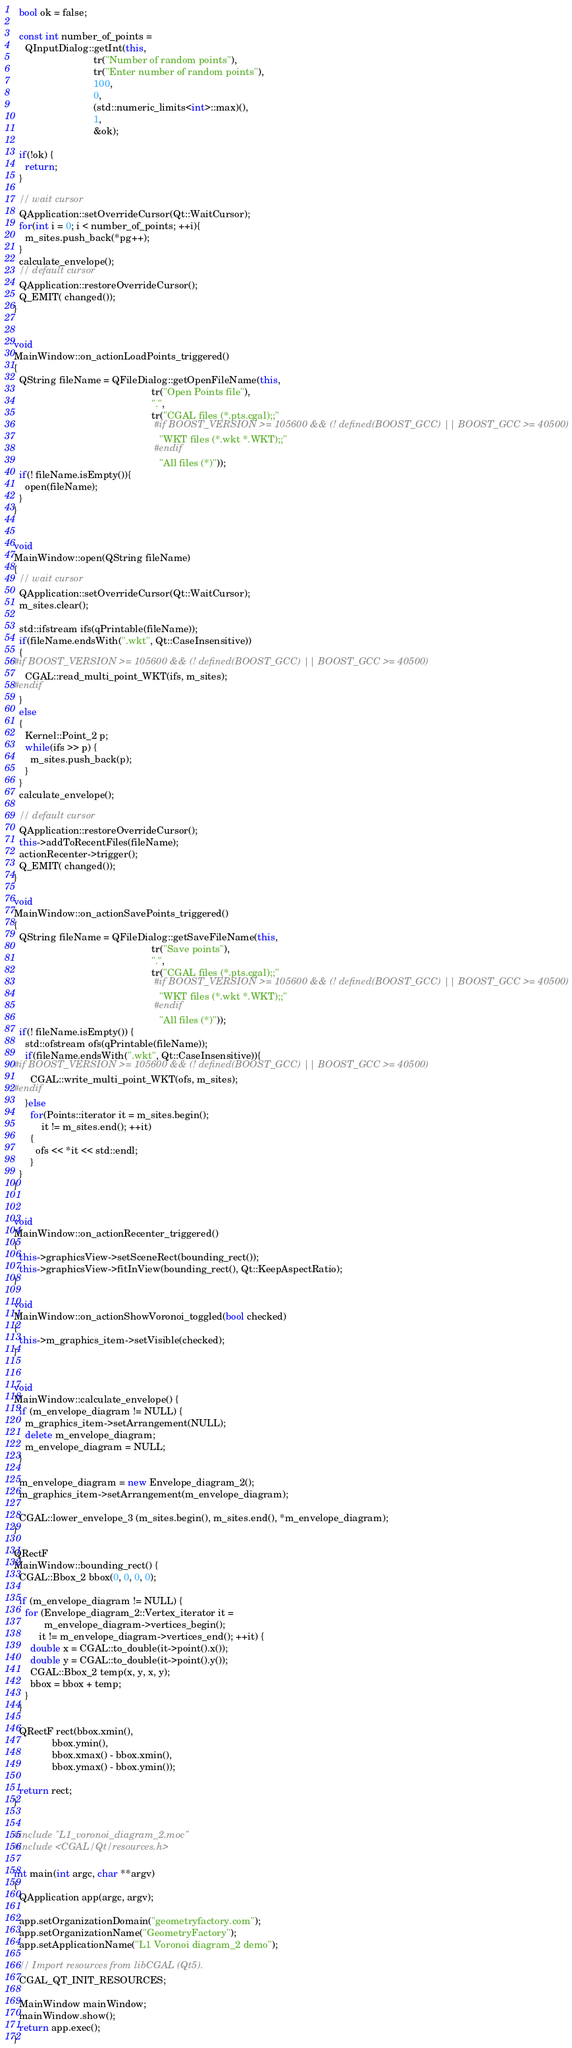<code> <loc_0><loc_0><loc_500><loc_500><_C++_>  bool ok = false;

  const int number_of_points =
    QInputDialog::getInt(this,
                             tr("Number of random points"),
                             tr("Enter number of random points"),
                             100,
                             0,
                             (std::numeric_limits<int>::max)(),
                             1,
                             &ok);

  if(!ok) {
    return;
  }

  // wait cursor
  QApplication::setOverrideCursor(Qt::WaitCursor);
  for(int i = 0; i < number_of_points; ++i){
    m_sites.push_back(*pg++);
  }
  calculate_envelope();
  // default cursor
  QApplication::restoreOverrideCursor();
  Q_EMIT( changed());
}


void
MainWindow::on_actionLoadPoints_triggered()
{
  QString fileName = QFileDialog::getOpenFileName(this,
                                                  tr("Open Points file"),
                                                  ".",
                                                  tr("CGAL files (*.pts.cgal);;"
                                                   #if BOOST_VERSION >= 105600 && (! defined(BOOST_GCC) || BOOST_GCC >= 40500)
                                                     "WKT files (*.wkt *.WKT);;"
                                                   #endif
                                                     "All files (*)"));
  if(! fileName.isEmpty()){
    open(fileName);
  }
}


void
MainWindow::open(QString fileName)
{
  // wait cursor
  QApplication::setOverrideCursor(Qt::WaitCursor);
  m_sites.clear();

  std::ifstream ifs(qPrintable(fileName));
  if(fileName.endsWith(".wkt", Qt::CaseInsensitive))
  {
#if BOOST_VERSION >= 105600 && (! defined(BOOST_GCC) || BOOST_GCC >= 40500)
    CGAL::read_multi_point_WKT(ifs, m_sites);
#endif
  }
  else
  {
    Kernel::Point_2 p;
    while(ifs >> p) {
      m_sites.push_back(p);
    }
  }
  calculate_envelope();

  // default cursor
  QApplication::restoreOverrideCursor();
  this->addToRecentFiles(fileName);
  actionRecenter->trigger();
  Q_EMIT( changed());
}

void
MainWindow::on_actionSavePoints_triggered()
{
  QString fileName = QFileDialog::getSaveFileName(this,
                                                  tr("Save points"),
                                                  ".",
                                                  tr("CGAL files (*.pts.cgal);;"
                                                   #if BOOST_VERSION >= 105600 && (! defined(BOOST_GCC) || BOOST_GCC >= 40500)
                                                     "WKT files (*.wkt *.WKT);;"
                                                   #endif
                                                     "All files (*)"));
  if(! fileName.isEmpty()) {
    std::ofstream ofs(qPrintable(fileName));
    if(fileName.endsWith(".wkt", Qt::CaseInsensitive)){
#if BOOST_VERSION >= 105600 && (! defined(BOOST_GCC) || BOOST_GCC >= 40500)
      CGAL::write_multi_point_WKT(ofs, m_sites);
#endif
    }else
      for(Points::iterator it = m_sites.begin();
          it != m_sites.end(); ++it)
      {
        ofs << *it << std::endl;
      }
  }
}


void
MainWindow::on_actionRecenter_triggered()
{
  this->graphicsView->setSceneRect(bounding_rect());
  this->graphicsView->fitInView(bounding_rect(), Qt::KeepAspectRatio);
}

void
MainWindow::on_actionShowVoronoi_toggled(bool checked)
{
  this->m_graphics_item->setVisible(checked);
}


void
MainWindow::calculate_envelope() {
  if (m_envelope_diagram != NULL) {
    m_graphics_item->setArrangement(NULL);
    delete m_envelope_diagram;
    m_envelope_diagram = NULL;
  }

  m_envelope_diagram = new Envelope_diagram_2();
  m_graphics_item->setArrangement(m_envelope_diagram);

  CGAL::lower_envelope_3 (m_sites.begin(), m_sites.end(), *m_envelope_diagram);
}

QRectF
MainWindow::bounding_rect() {
  CGAL::Bbox_2 bbox(0, 0, 0, 0);

  if (m_envelope_diagram != NULL) {
    for (Envelope_diagram_2::Vertex_iterator it =
           m_envelope_diagram->vertices_begin();
         it != m_envelope_diagram->vertices_end(); ++it) {
      double x = CGAL::to_double(it->point().x());
      double y = CGAL::to_double(it->point().y());
      CGAL::Bbox_2 temp(x, y, x, y);
      bbox = bbox + temp;
    }
  }

  QRectF rect(bbox.xmin(),
              bbox.ymin(),
              bbox.xmax() - bbox.xmin(),
              bbox.ymax() - bbox.ymin());

  return rect;
}


#include "L1_voronoi_diagram_2.moc"
#include <CGAL/Qt/resources.h>

int main(int argc, char **argv)
{
  QApplication app(argc, argv);

  app.setOrganizationDomain("geometryfactory.com");
  app.setOrganizationName("GeometryFactory");
  app.setApplicationName("L1 Voronoi diagram_2 demo");

  // Import resources from libCGAL (Qt5).
  CGAL_QT_INIT_RESOURCES;

  MainWindow mainWindow;
  mainWindow.show();
  return app.exec();
}

</code> 